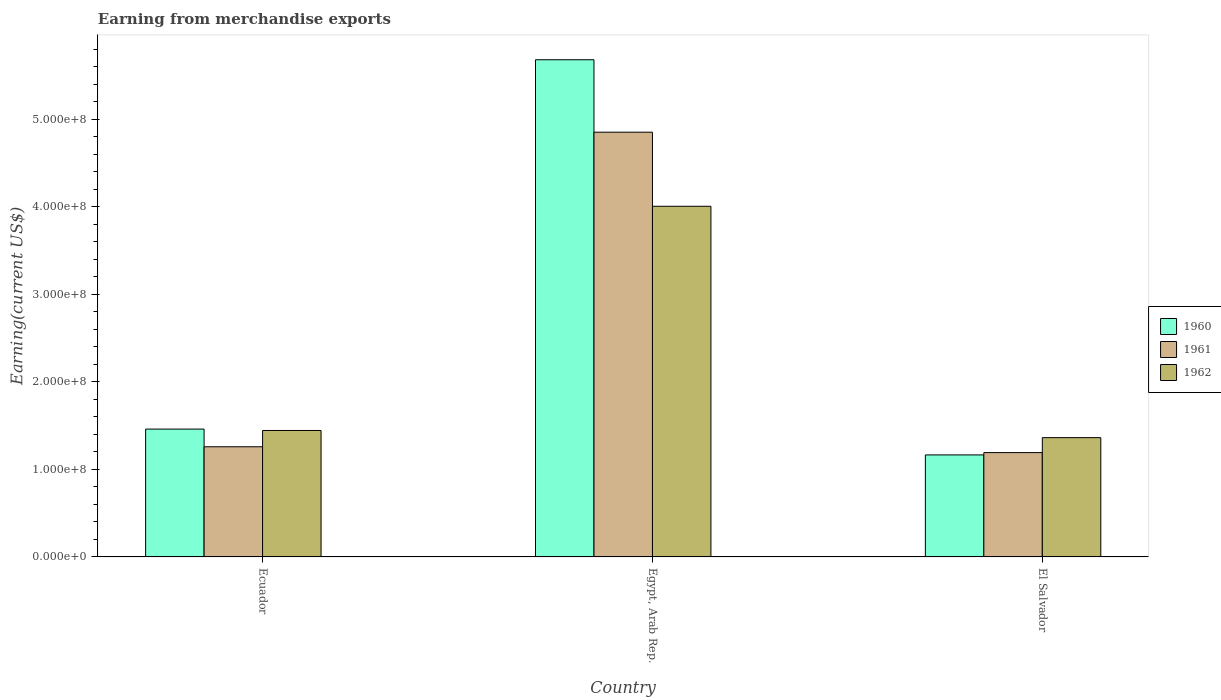How many different coloured bars are there?
Provide a short and direct response. 3. How many groups of bars are there?
Make the answer very short. 3. Are the number of bars on each tick of the X-axis equal?
Offer a terse response. Yes. How many bars are there on the 1st tick from the left?
Provide a short and direct response. 3. What is the label of the 3rd group of bars from the left?
Provide a succinct answer. El Salvador. What is the amount earned from merchandise exports in 1961 in Ecuador?
Keep it short and to the point. 1.26e+08. Across all countries, what is the maximum amount earned from merchandise exports in 1961?
Provide a succinct answer. 4.85e+08. Across all countries, what is the minimum amount earned from merchandise exports in 1961?
Offer a terse response. 1.19e+08. In which country was the amount earned from merchandise exports in 1961 maximum?
Your response must be concise. Egypt, Arab Rep. In which country was the amount earned from merchandise exports in 1961 minimum?
Provide a short and direct response. El Salvador. What is the total amount earned from merchandise exports in 1961 in the graph?
Offer a very short reply. 7.30e+08. What is the difference between the amount earned from merchandise exports in 1962 in Egypt, Arab Rep. and that in El Salvador?
Offer a very short reply. 2.64e+08. What is the difference between the amount earned from merchandise exports in 1962 in Egypt, Arab Rep. and the amount earned from merchandise exports in 1961 in El Salvador?
Your response must be concise. 2.81e+08. What is the average amount earned from merchandise exports in 1960 per country?
Provide a succinct answer. 2.77e+08. What is the difference between the amount earned from merchandise exports of/in 1960 and amount earned from merchandise exports of/in 1961 in El Salvador?
Ensure brevity in your answer.  -2.64e+06. In how many countries, is the amount earned from merchandise exports in 1962 greater than 240000000 US$?
Your response must be concise. 1. What is the ratio of the amount earned from merchandise exports in 1962 in Ecuador to that in El Salvador?
Provide a short and direct response. 1.06. Is the difference between the amount earned from merchandise exports in 1960 in Ecuador and Egypt, Arab Rep. greater than the difference between the amount earned from merchandise exports in 1961 in Ecuador and Egypt, Arab Rep.?
Keep it short and to the point. No. What is the difference between the highest and the second highest amount earned from merchandise exports in 1961?
Your answer should be very brief. 3.59e+08. What is the difference between the highest and the lowest amount earned from merchandise exports in 1962?
Offer a very short reply. 2.64e+08. What does the 2nd bar from the left in Egypt, Arab Rep. represents?
Your answer should be compact. 1961. How many bars are there?
Ensure brevity in your answer.  9. Does the graph contain any zero values?
Provide a succinct answer. No. How are the legend labels stacked?
Offer a very short reply. Vertical. What is the title of the graph?
Your answer should be very brief. Earning from merchandise exports. Does "1963" appear as one of the legend labels in the graph?
Provide a short and direct response. No. What is the label or title of the X-axis?
Your response must be concise. Country. What is the label or title of the Y-axis?
Provide a short and direct response. Earning(current US$). What is the Earning(current US$) of 1960 in Ecuador?
Offer a terse response. 1.46e+08. What is the Earning(current US$) in 1961 in Ecuador?
Offer a terse response. 1.26e+08. What is the Earning(current US$) of 1962 in Ecuador?
Offer a very short reply. 1.44e+08. What is the Earning(current US$) of 1960 in Egypt, Arab Rep.?
Your answer should be compact. 5.68e+08. What is the Earning(current US$) of 1961 in Egypt, Arab Rep.?
Your answer should be very brief. 4.85e+08. What is the Earning(current US$) in 1962 in Egypt, Arab Rep.?
Your answer should be very brief. 4.01e+08. What is the Earning(current US$) in 1960 in El Salvador?
Your answer should be very brief. 1.17e+08. What is the Earning(current US$) in 1961 in El Salvador?
Your answer should be compact. 1.19e+08. What is the Earning(current US$) in 1962 in El Salvador?
Your answer should be very brief. 1.36e+08. Across all countries, what is the maximum Earning(current US$) of 1960?
Your answer should be compact. 5.68e+08. Across all countries, what is the maximum Earning(current US$) in 1961?
Provide a succinct answer. 4.85e+08. Across all countries, what is the maximum Earning(current US$) in 1962?
Your response must be concise. 4.01e+08. Across all countries, what is the minimum Earning(current US$) of 1960?
Your answer should be very brief. 1.17e+08. Across all countries, what is the minimum Earning(current US$) of 1961?
Give a very brief answer. 1.19e+08. Across all countries, what is the minimum Earning(current US$) of 1962?
Provide a short and direct response. 1.36e+08. What is the total Earning(current US$) in 1960 in the graph?
Provide a short and direct response. 8.30e+08. What is the total Earning(current US$) of 1961 in the graph?
Make the answer very short. 7.30e+08. What is the total Earning(current US$) in 1962 in the graph?
Keep it short and to the point. 6.81e+08. What is the difference between the Earning(current US$) of 1960 in Ecuador and that in Egypt, Arab Rep.?
Your answer should be very brief. -4.22e+08. What is the difference between the Earning(current US$) of 1961 in Ecuador and that in Egypt, Arab Rep.?
Ensure brevity in your answer.  -3.59e+08. What is the difference between the Earning(current US$) in 1962 in Ecuador and that in Egypt, Arab Rep.?
Your answer should be very brief. -2.56e+08. What is the difference between the Earning(current US$) in 1960 in Ecuador and that in El Salvador?
Keep it short and to the point. 2.95e+07. What is the difference between the Earning(current US$) in 1961 in Ecuador and that in El Salvador?
Keep it short and to the point. 6.65e+06. What is the difference between the Earning(current US$) in 1962 in Ecuador and that in El Salvador?
Provide a short and direct response. 8.19e+06. What is the difference between the Earning(current US$) in 1960 in Egypt, Arab Rep. and that in El Salvador?
Give a very brief answer. 4.51e+08. What is the difference between the Earning(current US$) in 1961 in Egypt, Arab Rep. and that in El Salvador?
Offer a very short reply. 3.66e+08. What is the difference between the Earning(current US$) in 1962 in Egypt, Arab Rep. and that in El Salvador?
Offer a terse response. 2.64e+08. What is the difference between the Earning(current US$) of 1960 in Ecuador and the Earning(current US$) of 1961 in Egypt, Arab Rep.?
Offer a very short reply. -3.39e+08. What is the difference between the Earning(current US$) of 1960 in Ecuador and the Earning(current US$) of 1962 in Egypt, Arab Rep.?
Provide a short and direct response. -2.54e+08. What is the difference between the Earning(current US$) in 1961 in Ecuador and the Earning(current US$) in 1962 in Egypt, Arab Rep.?
Keep it short and to the point. -2.75e+08. What is the difference between the Earning(current US$) of 1960 in Ecuador and the Earning(current US$) of 1961 in El Salvador?
Your response must be concise. 2.69e+07. What is the difference between the Earning(current US$) in 1960 in Ecuador and the Earning(current US$) in 1962 in El Salvador?
Your answer should be compact. 9.77e+06. What is the difference between the Earning(current US$) in 1961 in Ecuador and the Earning(current US$) in 1962 in El Salvador?
Your answer should be very brief. -1.04e+07. What is the difference between the Earning(current US$) of 1960 in Egypt, Arab Rep. and the Earning(current US$) of 1961 in El Salvador?
Provide a short and direct response. 4.49e+08. What is the difference between the Earning(current US$) in 1960 in Egypt, Arab Rep. and the Earning(current US$) in 1962 in El Salvador?
Offer a terse response. 4.32e+08. What is the difference between the Earning(current US$) of 1961 in Egypt, Arab Rep. and the Earning(current US$) of 1962 in El Salvador?
Your response must be concise. 3.49e+08. What is the average Earning(current US$) in 1960 per country?
Keep it short and to the point. 2.77e+08. What is the average Earning(current US$) of 1961 per country?
Provide a short and direct response. 2.43e+08. What is the average Earning(current US$) in 1962 per country?
Provide a succinct answer. 2.27e+08. What is the difference between the Earning(current US$) of 1960 and Earning(current US$) of 1961 in Ecuador?
Provide a short and direct response. 2.02e+07. What is the difference between the Earning(current US$) in 1960 and Earning(current US$) in 1962 in Ecuador?
Provide a succinct answer. 1.58e+06. What is the difference between the Earning(current US$) of 1961 and Earning(current US$) of 1962 in Ecuador?
Your response must be concise. -1.86e+07. What is the difference between the Earning(current US$) of 1960 and Earning(current US$) of 1961 in Egypt, Arab Rep.?
Ensure brevity in your answer.  8.28e+07. What is the difference between the Earning(current US$) in 1960 and Earning(current US$) in 1962 in Egypt, Arab Rep.?
Offer a very short reply. 1.67e+08. What is the difference between the Earning(current US$) in 1961 and Earning(current US$) in 1962 in Egypt, Arab Rep.?
Offer a terse response. 8.46e+07. What is the difference between the Earning(current US$) in 1960 and Earning(current US$) in 1961 in El Salvador?
Provide a succinct answer. -2.64e+06. What is the difference between the Earning(current US$) in 1960 and Earning(current US$) in 1962 in El Salvador?
Give a very brief answer. -1.97e+07. What is the difference between the Earning(current US$) in 1961 and Earning(current US$) in 1962 in El Salvador?
Provide a succinct answer. -1.71e+07. What is the ratio of the Earning(current US$) in 1960 in Ecuador to that in Egypt, Arab Rep.?
Offer a terse response. 0.26. What is the ratio of the Earning(current US$) in 1961 in Ecuador to that in Egypt, Arab Rep.?
Your response must be concise. 0.26. What is the ratio of the Earning(current US$) in 1962 in Ecuador to that in Egypt, Arab Rep.?
Your response must be concise. 0.36. What is the ratio of the Earning(current US$) in 1960 in Ecuador to that in El Salvador?
Provide a short and direct response. 1.25. What is the ratio of the Earning(current US$) of 1961 in Ecuador to that in El Salvador?
Your answer should be very brief. 1.06. What is the ratio of the Earning(current US$) in 1962 in Ecuador to that in El Salvador?
Your answer should be very brief. 1.06. What is the ratio of the Earning(current US$) of 1960 in Egypt, Arab Rep. to that in El Salvador?
Ensure brevity in your answer.  4.87. What is the ratio of the Earning(current US$) in 1961 in Egypt, Arab Rep. to that in El Salvador?
Provide a short and direct response. 4.07. What is the ratio of the Earning(current US$) in 1962 in Egypt, Arab Rep. to that in El Salvador?
Offer a very short reply. 2.94. What is the difference between the highest and the second highest Earning(current US$) of 1960?
Ensure brevity in your answer.  4.22e+08. What is the difference between the highest and the second highest Earning(current US$) of 1961?
Your answer should be very brief. 3.59e+08. What is the difference between the highest and the second highest Earning(current US$) of 1962?
Offer a very short reply. 2.56e+08. What is the difference between the highest and the lowest Earning(current US$) in 1960?
Provide a succinct answer. 4.51e+08. What is the difference between the highest and the lowest Earning(current US$) of 1961?
Your answer should be compact. 3.66e+08. What is the difference between the highest and the lowest Earning(current US$) of 1962?
Provide a succinct answer. 2.64e+08. 